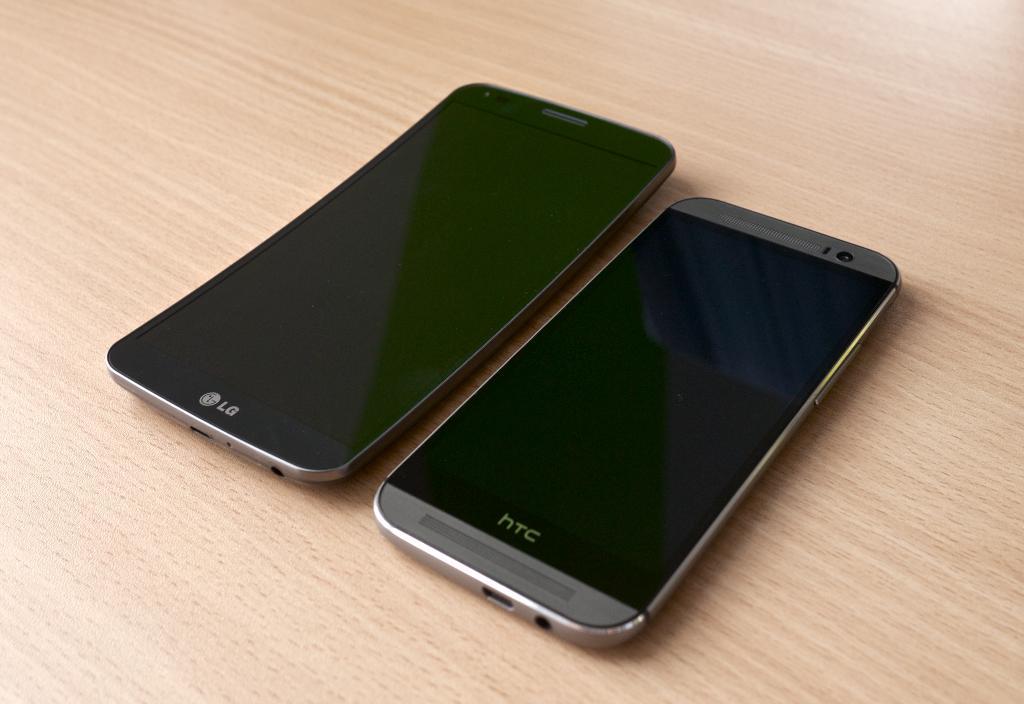What brand is the phone on the right?
Your answer should be compact. Htc. What brand is the phone on the left?
Provide a short and direct response. Lg. 